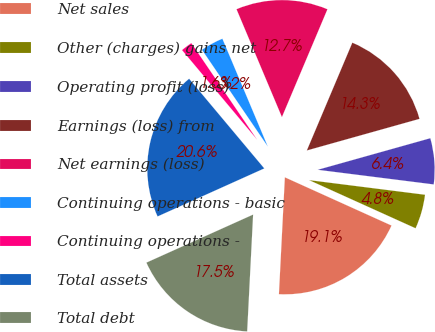Convert chart to OTSL. <chart><loc_0><loc_0><loc_500><loc_500><pie_chart><fcel>Net sales<fcel>Other (charges) gains net<fcel>Operating profit (loss)<fcel>Earnings (loss) from<fcel>Net earnings (loss)<fcel>Continuing operations - basic<fcel>Continuing operations -<fcel>Total assets<fcel>Total debt<nl><fcel>19.05%<fcel>4.76%<fcel>6.35%<fcel>14.29%<fcel>12.7%<fcel>3.17%<fcel>1.59%<fcel>20.63%<fcel>17.46%<nl></chart> 